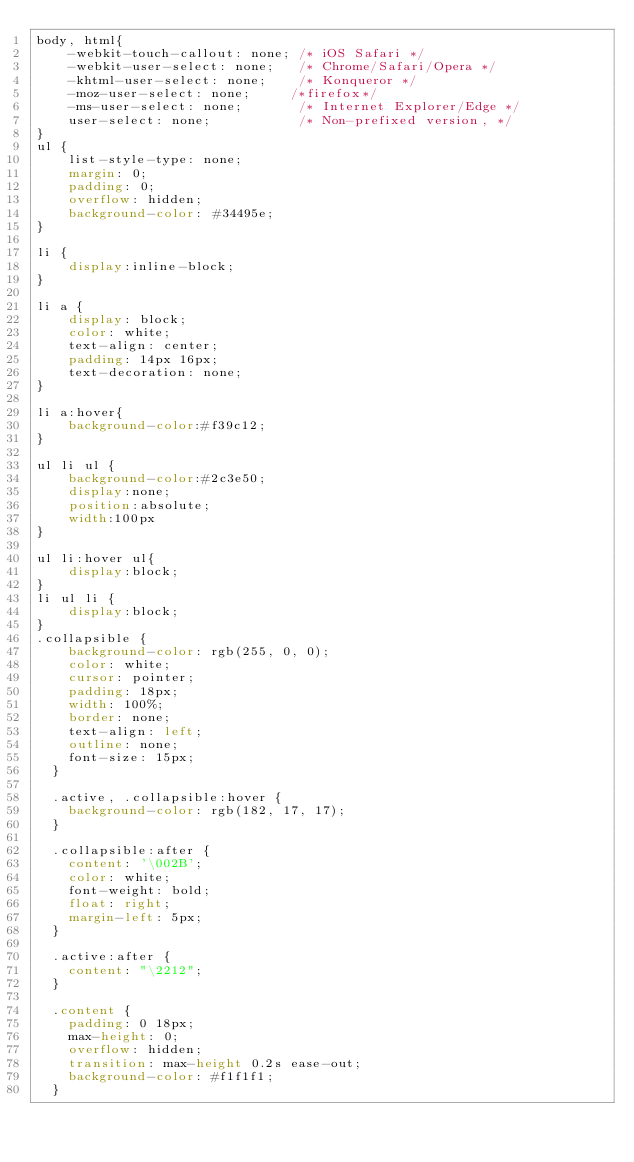Convert code to text. <code><loc_0><loc_0><loc_500><loc_500><_CSS_>body, html{
    -webkit-touch-callout: none; /* iOS Safari */
    -webkit-user-select: none;   /* Chrome/Safari/Opera */
    -khtml-user-select: none;    /* Konqueror */ 
    -moz-user-select: none;     /*firefox*/
    -ms-user-select: none;       /* Internet Explorer/Edge */
    user-select: none;           /* Non-prefixed version, */
}
ul {
    list-style-type: none;
    margin: 0;
    padding: 0;
    overflow: hidden;
    background-color: #34495e;
}

li {
    display:inline-block;
}

li a {
    display: block;
    color: white;
    text-align: center;
    padding: 14px 16px;
    text-decoration: none;
}

li a:hover{
    background-color:#f39c12; 
}

ul li ul {
    background-color:#2c3e50;
    display:none;
    position:absolute;
    width:100px
}

ul li:hover ul{
    display:block;
}
li ul li {
    display:block; 
}
.collapsible {
    background-color: rgb(255, 0, 0);
    color: white;
    cursor: pointer;
    padding: 18px;
    width: 100%;
    border: none;
    text-align: left;
    outline: none;
    font-size: 15px;
  }
  
  .active, .collapsible:hover {
    background-color: rgb(182, 17, 17);
  }
  
  .collapsible:after {
    content: '\002B';
    color: white;
    font-weight: bold;
    float: right;
    margin-left: 5px;
  }
  
  .active:after {
    content: "\2212";
  }
  
  .content {
    padding: 0 18px;
    max-height: 0;
    overflow: hidden;
    transition: max-height 0.2s ease-out;
    background-color: #f1f1f1;
  }</code> 